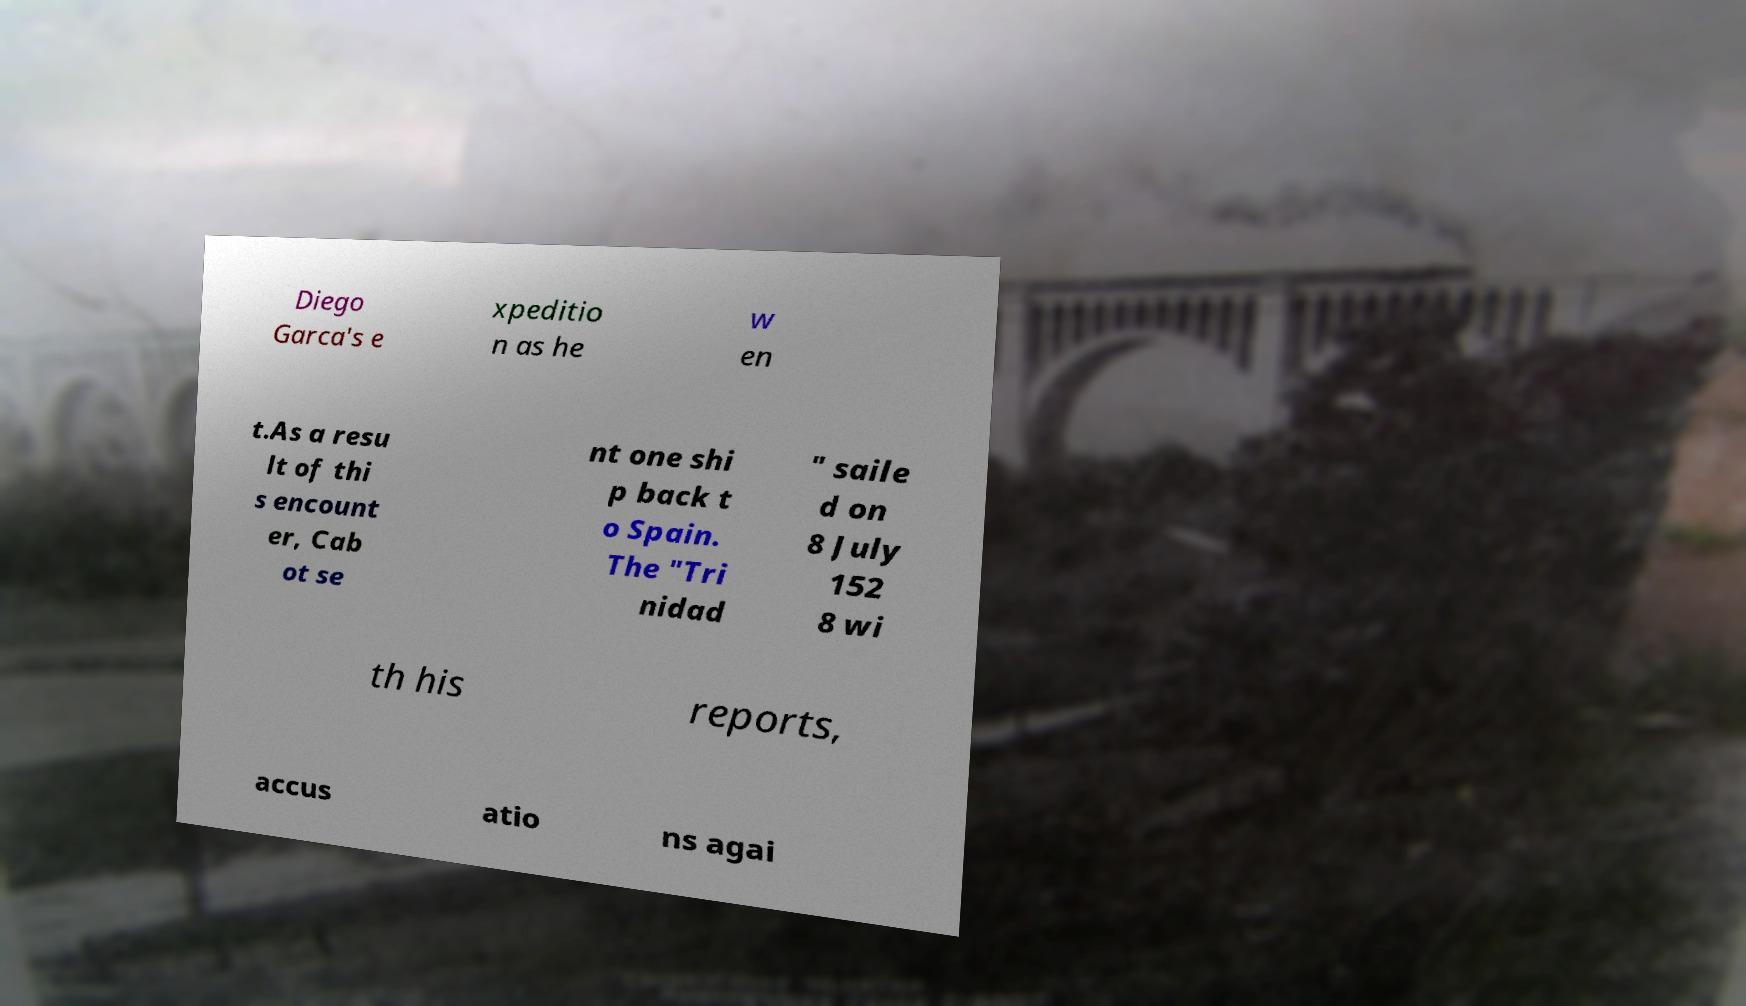I need the written content from this picture converted into text. Can you do that? Diego Garca's e xpeditio n as he w en t.As a resu lt of thi s encount er, Cab ot se nt one shi p back t o Spain. The "Tri nidad " saile d on 8 July 152 8 wi th his reports, accus atio ns agai 